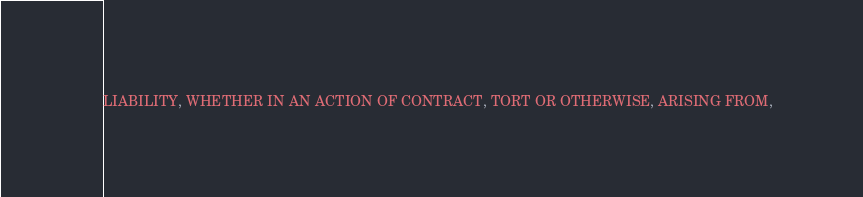<code> <loc_0><loc_0><loc_500><loc_500><_JavaScript_>LIABILITY, WHETHER IN AN ACTION OF CONTRACT, TORT OR OTHERWISE, ARISING FROM,</code> 